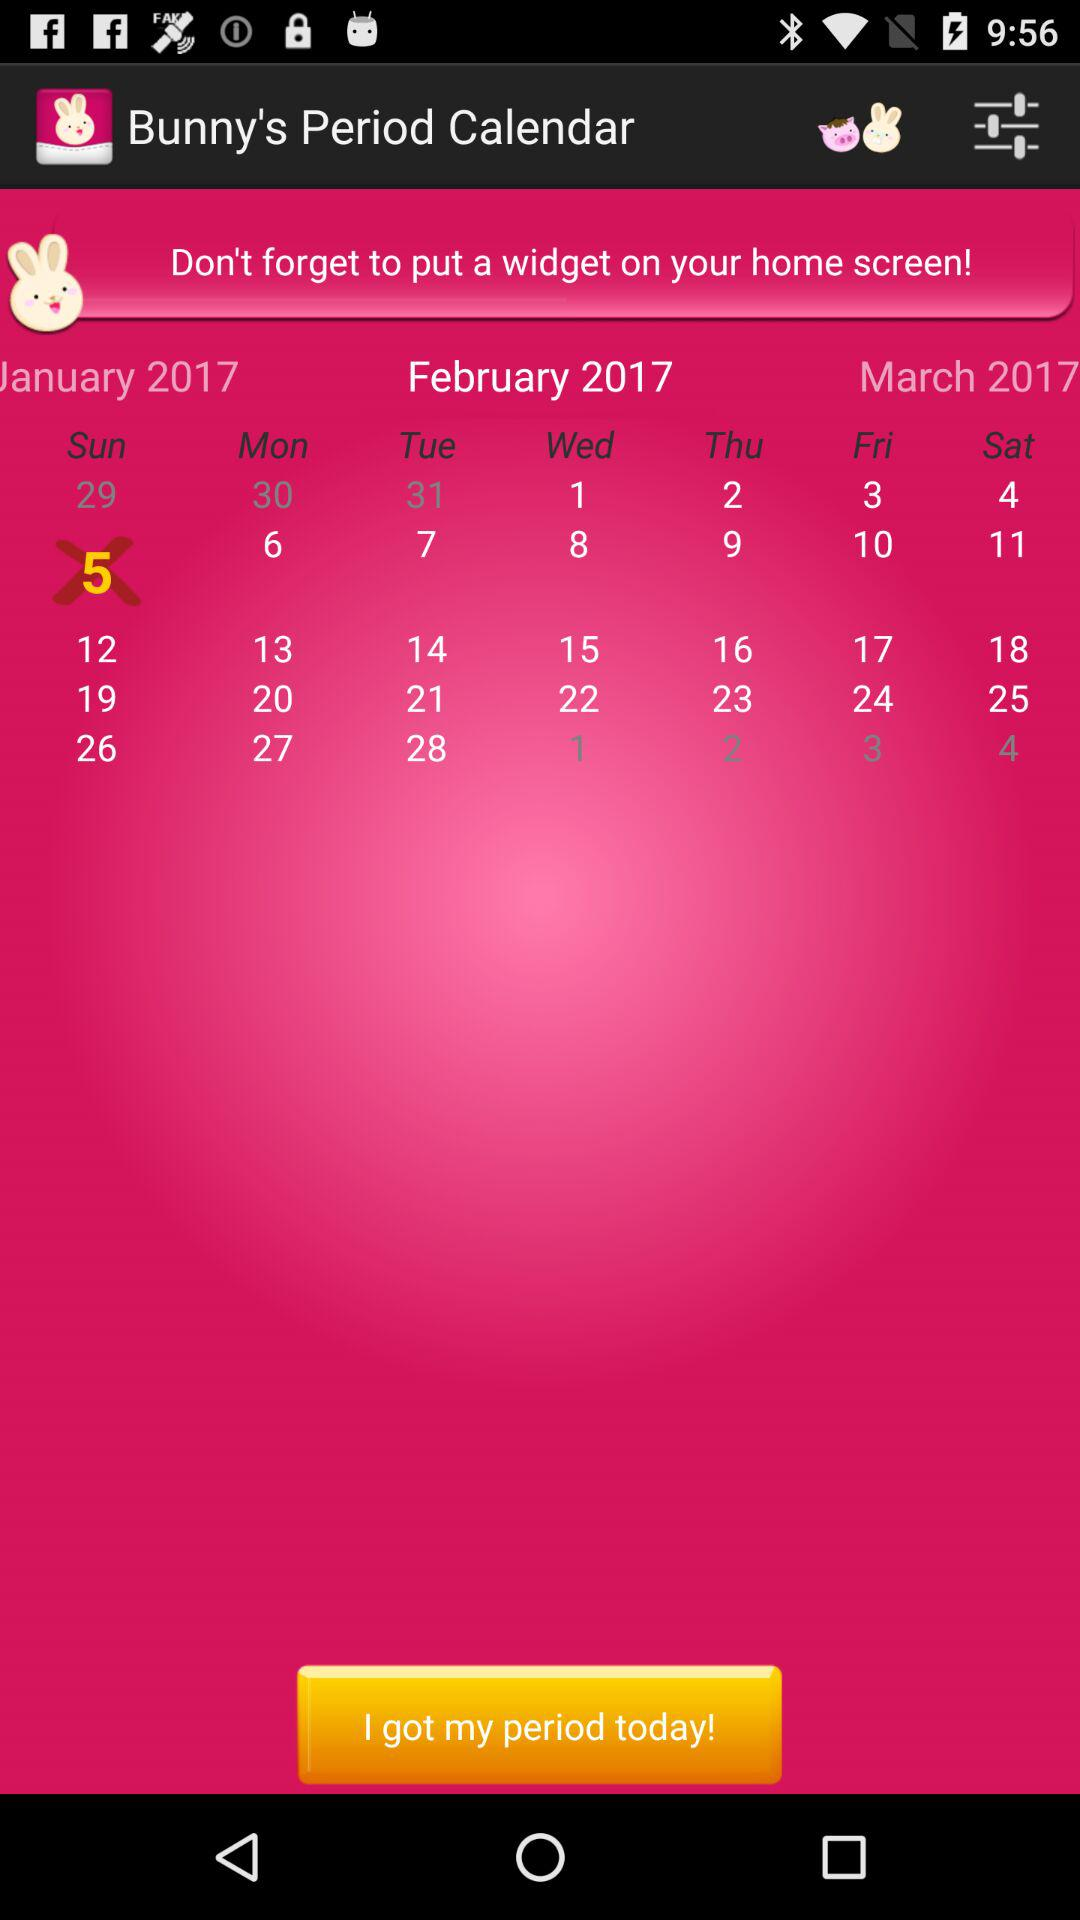Which day falls on February 5th, 2017? The day that falls on February 5th, 2017 is Sunday. 